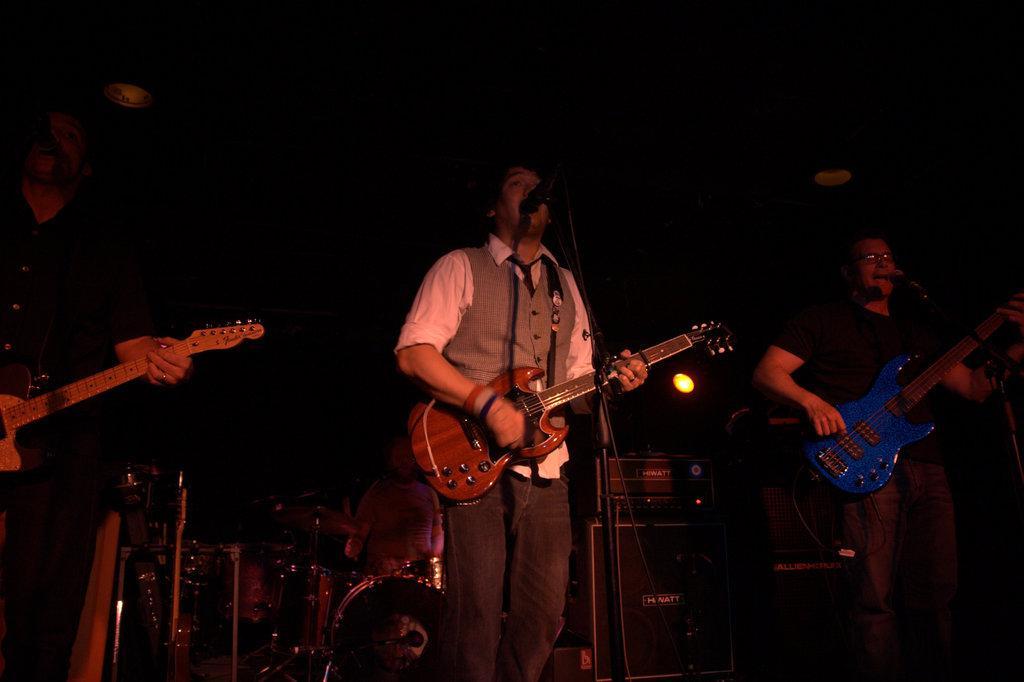Could you give a brief overview of what you see in this image? In this picture there are three members standing and playing guitars in their hands in front of the mic. In the background there is another guy playing drums and some speakers here. 